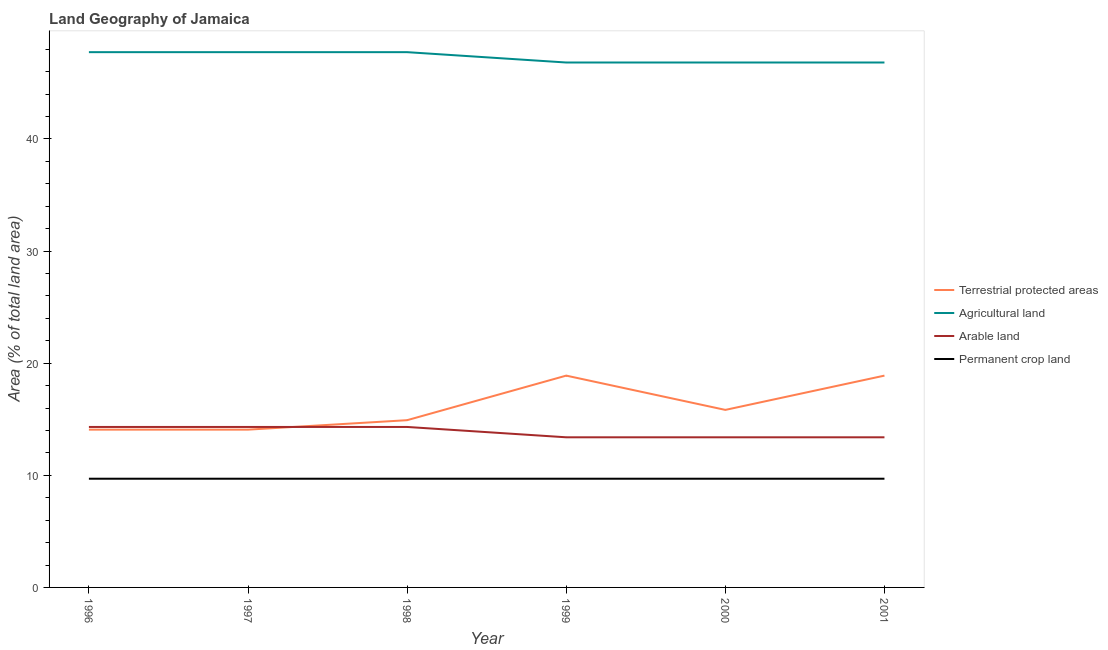How many different coloured lines are there?
Ensure brevity in your answer.  4. Does the line corresponding to percentage of land under terrestrial protection intersect with the line corresponding to percentage of area under permanent crop land?
Give a very brief answer. No. What is the percentage of area under agricultural land in 1997?
Offer a very short reply. 47.74. Across all years, what is the maximum percentage of area under permanent crop land?
Make the answer very short. 9.7. Across all years, what is the minimum percentage of area under permanent crop land?
Provide a short and direct response. 9.7. In which year was the percentage of area under permanent crop land minimum?
Your answer should be compact. 1996. What is the total percentage of area under agricultural land in the graph?
Give a very brief answer. 283.66. What is the difference between the percentage of area under agricultural land in 1996 and that in 2000?
Provide a short and direct response. 0.92. What is the difference between the percentage of land under terrestrial protection in 2001 and the percentage of area under permanent crop land in 1998?
Ensure brevity in your answer.  9.19. What is the average percentage of land under terrestrial protection per year?
Offer a terse response. 16.11. In the year 1997, what is the difference between the percentage of land under terrestrial protection and percentage of area under permanent crop land?
Ensure brevity in your answer.  4.38. What is the ratio of the percentage of land under terrestrial protection in 1998 to that in 2000?
Keep it short and to the point. 0.94. Is the percentage of area under arable land in 1999 less than that in 2001?
Provide a short and direct response. No. What is the difference between the highest and the lowest percentage of land under terrestrial protection?
Your answer should be compact. 4.82. Is the sum of the percentage of area under arable land in 1998 and 2001 greater than the maximum percentage of land under terrestrial protection across all years?
Provide a succinct answer. Yes. Does the percentage of land under terrestrial protection monotonically increase over the years?
Offer a terse response. No. Is the percentage of area under arable land strictly less than the percentage of land under terrestrial protection over the years?
Your answer should be compact. No. Are the values on the major ticks of Y-axis written in scientific E-notation?
Give a very brief answer. No. How many legend labels are there?
Make the answer very short. 4. What is the title of the graph?
Your answer should be very brief. Land Geography of Jamaica. Does "Business regulatory environment" appear as one of the legend labels in the graph?
Provide a short and direct response. No. What is the label or title of the X-axis?
Offer a very short reply. Year. What is the label or title of the Y-axis?
Your answer should be compact. Area (% of total land area). What is the Area (% of total land area) in Terrestrial protected areas in 1996?
Ensure brevity in your answer.  14.07. What is the Area (% of total land area) in Agricultural land in 1996?
Provide a succinct answer. 47.74. What is the Area (% of total land area) of Arable land in 1996?
Your answer should be very brief. 14.31. What is the Area (% of total land area) of Permanent crop land in 1996?
Make the answer very short. 9.7. What is the Area (% of total land area) in Terrestrial protected areas in 1997?
Your answer should be compact. 14.07. What is the Area (% of total land area) of Agricultural land in 1997?
Keep it short and to the point. 47.74. What is the Area (% of total land area) of Arable land in 1997?
Your response must be concise. 14.31. What is the Area (% of total land area) of Permanent crop land in 1997?
Ensure brevity in your answer.  9.7. What is the Area (% of total land area) in Terrestrial protected areas in 1998?
Your answer should be very brief. 14.92. What is the Area (% of total land area) of Agricultural land in 1998?
Ensure brevity in your answer.  47.74. What is the Area (% of total land area) of Arable land in 1998?
Keep it short and to the point. 14.31. What is the Area (% of total land area) in Permanent crop land in 1998?
Provide a succinct answer. 9.7. What is the Area (% of total land area) of Terrestrial protected areas in 1999?
Make the answer very short. 18.89. What is the Area (% of total land area) of Agricultural land in 1999?
Offer a terse response. 46.81. What is the Area (% of total land area) of Arable land in 1999?
Your response must be concise. 13.39. What is the Area (% of total land area) in Permanent crop land in 1999?
Provide a short and direct response. 9.7. What is the Area (% of total land area) of Terrestrial protected areas in 2000?
Ensure brevity in your answer.  15.83. What is the Area (% of total land area) of Agricultural land in 2000?
Your answer should be very brief. 46.81. What is the Area (% of total land area) in Arable land in 2000?
Your answer should be very brief. 13.39. What is the Area (% of total land area) in Permanent crop land in 2000?
Your response must be concise. 9.7. What is the Area (% of total land area) in Terrestrial protected areas in 2001?
Provide a short and direct response. 18.89. What is the Area (% of total land area) in Agricultural land in 2001?
Give a very brief answer. 46.81. What is the Area (% of total land area) in Arable land in 2001?
Provide a succinct answer. 13.39. What is the Area (% of total land area) in Permanent crop land in 2001?
Provide a succinct answer. 9.7. Across all years, what is the maximum Area (% of total land area) in Terrestrial protected areas?
Provide a succinct answer. 18.89. Across all years, what is the maximum Area (% of total land area) of Agricultural land?
Your answer should be compact. 47.74. Across all years, what is the maximum Area (% of total land area) of Arable land?
Make the answer very short. 14.31. Across all years, what is the maximum Area (% of total land area) in Permanent crop land?
Give a very brief answer. 9.7. Across all years, what is the minimum Area (% of total land area) in Terrestrial protected areas?
Offer a very short reply. 14.07. Across all years, what is the minimum Area (% of total land area) in Agricultural land?
Provide a succinct answer. 46.81. Across all years, what is the minimum Area (% of total land area) in Arable land?
Give a very brief answer. 13.39. Across all years, what is the minimum Area (% of total land area) of Permanent crop land?
Offer a terse response. 9.7. What is the total Area (% of total land area) in Terrestrial protected areas in the graph?
Your answer should be compact. 96.67. What is the total Area (% of total land area) of Agricultural land in the graph?
Make the answer very short. 283.66. What is the total Area (% of total land area) of Arable land in the graph?
Keep it short and to the point. 83.1. What is the total Area (% of total land area) in Permanent crop land in the graph?
Make the answer very short. 58.17. What is the difference between the Area (% of total land area) in Terrestrial protected areas in 1996 and that in 1997?
Offer a terse response. 0. What is the difference between the Area (% of total land area) in Agricultural land in 1996 and that in 1997?
Your answer should be compact. 0. What is the difference between the Area (% of total land area) in Arable land in 1996 and that in 1997?
Offer a very short reply. 0. What is the difference between the Area (% of total land area) of Terrestrial protected areas in 1996 and that in 1998?
Your answer should be compact. -0.84. What is the difference between the Area (% of total land area) in Agricultural land in 1996 and that in 1998?
Your answer should be very brief. 0. What is the difference between the Area (% of total land area) in Arable land in 1996 and that in 1998?
Provide a succinct answer. 0. What is the difference between the Area (% of total land area) of Permanent crop land in 1996 and that in 1998?
Offer a very short reply. 0. What is the difference between the Area (% of total land area) of Terrestrial protected areas in 1996 and that in 1999?
Your answer should be very brief. -4.82. What is the difference between the Area (% of total land area) of Agricultural land in 1996 and that in 1999?
Offer a very short reply. 0.92. What is the difference between the Area (% of total land area) of Arable land in 1996 and that in 1999?
Give a very brief answer. 0.92. What is the difference between the Area (% of total land area) of Terrestrial protected areas in 1996 and that in 2000?
Offer a terse response. -1.76. What is the difference between the Area (% of total land area) in Agricultural land in 1996 and that in 2000?
Offer a terse response. 0.92. What is the difference between the Area (% of total land area) in Arable land in 1996 and that in 2000?
Your answer should be compact. 0.92. What is the difference between the Area (% of total land area) in Terrestrial protected areas in 1996 and that in 2001?
Provide a succinct answer. -4.82. What is the difference between the Area (% of total land area) in Agricultural land in 1996 and that in 2001?
Your answer should be compact. 0.92. What is the difference between the Area (% of total land area) in Arable land in 1996 and that in 2001?
Ensure brevity in your answer.  0.92. What is the difference between the Area (% of total land area) in Terrestrial protected areas in 1997 and that in 1998?
Offer a terse response. -0.84. What is the difference between the Area (% of total land area) in Permanent crop land in 1997 and that in 1998?
Your answer should be very brief. 0. What is the difference between the Area (% of total land area) in Terrestrial protected areas in 1997 and that in 1999?
Offer a very short reply. -4.82. What is the difference between the Area (% of total land area) in Agricultural land in 1997 and that in 1999?
Provide a succinct answer. 0.92. What is the difference between the Area (% of total land area) of Arable land in 1997 and that in 1999?
Offer a terse response. 0.92. What is the difference between the Area (% of total land area) in Terrestrial protected areas in 1997 and that in 2000?
Keep it short and to the point. -1.76. What is the difference between the Area (% of total land area) in Agricultural land in 1997 and that in 2000?
Your answer should be very brief. 0.92. What is the difference between the Area (% of total land area) in Arable land in 1997 and that in 2000?
Offer a terse response. 0.92. What is the difference between the Area (% of total land area) in Permanent crop land in 1997 and that in 2000?
Your answer should be compact. 0. What is the difference between the Area (% of total land area) in Terrestrial protected areas in 1997 and that in 2001?
Offer a terse response. -4.82. What is the difference between the Area (% of total land area) in Agricultural land in 1997 and that in 2001?
Keep it short and to the point. 0.92. What is the difference between the Area (% of total land area) of Arable land in 1997 and that in 2001?
Your response must be concise. 0.92. What is the difference between the Area (% of total land area) in Permanent crop land in 1997 and that in 2001?
Your answer should be very brief. 0. What is the difference between the Area (% of total land area) of Terrestrial protected areas in 1998 and that in 1999?
Provide a short and direct response. -3.97. What is the difference between the Area (% of total land area) in Agricultural land in 1998 and that in 1999?
Your response must be concise. 0.92. What is the difference between the Area (% of total land area) in Arable land in 1998 and that in 1999?
Make the answer very short. 0.92. What is the difference between the Area (% of total land area) of Terrestrial protected areas in 1998 and that in 2000?
Your answer should be compact. -0.92. What is the difference between the Area (% of total land area) of Agricultural land in 1998 and that in 2000?
Your response must be concise. 0.92. What is the difference between the Area (% of total land area) in Arable land in 1998 and that in 2000?
Offer a very short reply. 0.92. What is the difference between the Area (% of total land area) of Permanent crop land in 1998 and that in 2000?
Your response must be concise. 0. What is the difference between the Area (% of total land area) in Terrestrial protected areas in 1998 and that in 2001?
Provide a succinct answer. -3.97. What is the difference between the Area (% of total land area) of Agricultural land in 1998 and that in 2001?
Offer a very short reply. 0.92. What is the difference between the Area (% of total land area) in Arable land in 1998 and that in 2001?
Your answer should be compact. 0.92. What is the difference between the Area (% of total land area) in Terrestrial protected areas in 1999 and that in 2000?
Keep it short and to the point. 3.06. What is the difference between the Area (% of total land area) of Agricultural land in 1999 and that in 2000?
Provide a succinct answer. 0. What is the difference between the Area (% of total land area) in Arable land in 1999 and that in 2000?
Offer a very short reply. 0. What is the difference between the Area (% of total land area) in Terrestrial protected areas in 1999 and that in 2001?
Give a very brief answer. 0. What is the difference between the Area (% of total land area) of Agricultural land in 1999 and that in 2001?
Provide a succinct answer. 0. What is the difference between the Area (% of total land area) of Arable land in 1999 and that in 2001?
Ensure brevity in your answer.  0. What is the difference between the Area (% of total land area) of Terrestrial protected areas in 2000 and that in 2001?
Your answer should be very brief. -3.06. What is the difference between the Area (% of total land area) of Agricultural land in 2000 and that in 2001?
Your response must be concise. 0. What is the difference between the Area (% of total land area) in Terrestrial protected areas in 1996 and the Area (% of total land area) in Agricultural land in 1997?
Your answer should be very brief. -33.67. What is the difference between the Area (% of total land area) of Terrestrial protected areas in 1996 and the Area (% of total land area) of Arable land in 1997?
Provide a short and direct response. -0.24. What is the difference between the Area (% of total land area) in Terrestrial protected areas in 1996 and the Area (% of total land area) in Permanent crop land in 1997?
Ensure brevity in your answer.  4.38. What is the difference between the Area (% of total land area) in Agricultural land in 1996 and the Area (% of total land area) in Arable land in 1997?
Provide a succinct answer. 33.43. What is the difference between the Area (% of total land area) of Agricultural land in 1996 and the Area (% of total land area) of Permanent crop land in 1997?
Offer a very short reply. 38.04. What is the difference between the Area (% of total land area) of Arable land in 1996 and the Area (% of total land area) of Permanent crop land in 1997?
Provide a succinct answer. 4.62. What is the difference between the Area (% of total land area) in Terrestrial protected areas in 1996 and the Area (% of total land area) in Agricultural land in 1998?
Your response must be concise. -33.67. What is the difference between the Area (% of total land area) of Terrestrial protected areas in 1996 and the Area (% of total land area) of Arable land in 1998?
Your response must be concise. -0.24. What is the difference between the Area (% of total land area) of Terrestrial protected areas in 1996 and the Area (% of total land area) of Permanent crop land in 1998?
Your answer should be very brief. 4.38. What is the difference between the Area (% of total land area) in Agricultural land in 1996 and the Area (% of total land area) in Arable land in 1998?
Provide a short and direct response. 33.43. What is the difference between the Area (% of total land area) of Agricultural land in 1996 and the Area (% of total land area) of Permanent crop land in 1998?
Provide a short and direct response. 38.04. What is the difference between the Area (% of total land area) of Arable land in 1996 and the Area (% of total land area) of Permanent crop land in 1998?
Your answer should be very brief. 4.62. What is the difference between the Area (% of total land area) of Terrestrial protected areas in 1996 and the Area (% of total land area) of Agricultural land in 1999?
Your response must be concise. -32.74. What is the difference between the Area (% of total land area) in Terrestrial protected areas in 1996 and the Area (% of total land area) in Arable land in 1999?
Offer a terse response. 0.68. What is the difference between the Area (% of total land area) in Terrestrial protected areas in 1996 and the Area (% of total land area) in Permanent crop land in 1999?
Provide a short and direct response. 4.38. What is the difference between the Area (% of total land area) of Agricultural land in 1996 and the Area (% of total land area) of Arable land in 1999?
Give a very brief answer. 34.35. What is the difference between the Area (% of total land area) in Agricultural land in 1996 and the Area (% of total land area) in Permanent crop land in 1999?
Your answer should be very brief. 38.04. What is the difference between the Area (% of total land area) in Arable land in 1996 and the Area (% of total land area) in Permanent crop land in 1999?
Provide a short and direct response. 4.62. What is the difference between the Area (% of total land area) of Terrestrial protected areas in 1996 and the Area (% of total land area) of Agricultural land in 2000?
Make the answer very short. -32.74. What is the difference between the Area (% of total land area) in Terrestrial protected areas in 1996 and the Area (% of total land area) in Arable land in 2000?
Provide a succinct answer. 0.68. What is the difference between the Area (% of total land area) of Terrestrial protected areas in 1996 and the Area (% of total land area) of Permanent crop land in 2000?
Your response must be concise. 4.38. What is the difference between the Area (% of total land area) of Agricultural land in 1996 and the Area (% of total land area) of Arable land in 2000?
Your answer should be compact. 34.35. What is the difference between the Area (% of total land area) of Agricultural land in 1996 and the Area (% of total land area) of Permanent crop land in 2000?
Give a very brief answer. 38.04. What is the difference between the Area (% of total land area) in Arable land in 1996 and the Area (% of total land area) in Permanent crop land in 2000?
Offer a very short reply. 4.62. What is the difference between the Area (% of total land area) of Terrestrial protected areas in 1996 and the Area (% of total land area) of Agricultural land in 2001?
Your answer should be very brief. -32.74. What is the difference between the Area (% of total land area) in Terrestrial protected areas in 1996 and the Area (% of total land area) in Arable land in 2001?
Your answer should be compact. 0.68. What is the difference between the Area (% of total land area) of Terrestrial protected areas in 1996 and the Area (% of total land area) of Permanent crop land in 2001?
Offer a very short reply. 4.38. What is the difference between the Area (% of total land area) of Agricultural land in 1996 and the Area (% of total land area) of Arable land in 2001?
Make the answer very short. 34.35. What is the difference between the Area (% of total land area) in Agricultural land in 1996 and the Area (% of total land area) in Permanent crop land in 2001?
Your response must be concise. 38.04. What is the difference between the Area (% of total land area) of Arable land in 1996 and the Area (% of total land area) of Permanent crop land in 2001?
Ensure brevity in your answer.  4.62. What is the difference between the Area (% of total land area) in Terrestrial protected areas in 1997 and the Area (% of total land area) in Agricultural land in 1998?
Give a very brief answer. -33.67. What is the difference between the Area (% of total land area) in Terrestrial protected areas in 1997 and the Area (% of total land area) in Arable land in 1998?
Make the answer very short. -0.24. What is the difference between the Area (% of total land area) of Terrestrial protected areas in 1997 and the Area (% of total land area) of Permanent crop land in 1998?
Offer a very short reply. 4.38. What is the difference between the Area (% of total land area) of Agricultural land in 1997 and the Area (% of total land area) of Arable land in 1998?
Ensure brevity in your answer.  33.43. What is the difference between the Area (% of total land area) of Agricultural land in 1997 and the Area (% of total land area) of Permanent crop land in 1998?
Provide a short and direct response. 38.04. What is the difference between the Area (% of total land area) in Arable land in 1997 and the Area (% of total land area) in Permanent crop land in 1998?
Ensure brevity in your answer.  4.62. What is the difference between the Area (% of total land area) of Terrestrial protected areas in 1997 and the Area (% of total land area) of Agricultural land in 1999?
Make the answer very short. -32.74. What is the difference between the Area (% of total land area) in Terrestrial protected areas in 1997 and the Area (% of total land area) in Arable land in 1999?
Provide a succinct answer. 0.68. What is the difference between the Area (% of total land area) in Terrestrial protected areas in 1997 and the Area (% of total land area) in Permanent crop land in 1999?
Offer a terse response. 4.38. What is the difference between the Area (% of total land area) in Agricultural land in 1997 and the Area (% of total land area) in Arable land in 1999?
Provide a succinct answer. 34.35. What is the difference between the Area (% of total land area) of Agricultural land in 1997 and the Area (% of total land area) of Permanent crop land in 1999?
Make the answer very short. 38.04. What is the difference between the Area (% of total land area) of Arable land in 1997 and the Area (% of total land area) of Permanent crop land in 1999?
Provide a short and direct response. 4.62. What is the difference between the Area (% of total land area) in Terrestrial protected areas in 1997 and the Area (% of total land area) in Agricultural land in 2000?
Your response must be concise. -32.74. What is the difference between the Area (% of total land area) in Terrestrial protected areas in 1997 and the Area (% of total land area) in Arable land in 2000?
Make the answer very short. 0.68. What is the difference between the Area (% of total land area) of Terrestrial protected areas in 1997 and the Area (% of total land area) of Permanent crop land in 2000?
Provide a succinct answer. 4.38. What is the difference between the Area (% of total land area) in Agricultural land in 1997 and the Area (% of total land area) in Arable land in 2000?
Your answer should be very brief. 34.35. What is the difference between the Area (% of total land area) in Agricultural land in 1997 and the Area (% of total land area) in Permanent crop land in 2000?
Give a very brief answer. 38.04. What is the difference between the Area (% of total land area) in Arable land in 1997 and the Area (% of total land area) in Permanent crop land in 2000?
Give a very brief answer. 4.62. What is the difference between the Area (% of total land area) in Terrestrial protected areas in 1997 and the Area (% of total land area) in Agricultural land in 2001?
Provide a succinct answer. -32.74. What is the difference between the Area (% of total land area) in Terrestrial protected areas in 1997 and the Area (% of total land area) in Arable land in 2001?
Provide a short and direct response. 0.68. What is the difference between the Area (% of total land area) in Terrestrial protected areas in 1997 and the Area (% of total land area) in Permanent crop land in 2001?
Give a very brief answer. 4.38. What is the difference between the Area (% of total land area) in Agricultural land in 1997 and the Area (% of total land area) in Arable land in 2001?
Keep it short and to the point. 34.35. What is the difference between the Area (% of total land area) of Agricultural land in 1997 and the Area (% of total land area) of Permanent crop land in 2001?
Your answer should be very brief. 38.04. What is the difference between the Area (% of total land area) in Arable land in 1997 and the Area (% of total land area) in Permanent crop land in 2001?
Ensure brevity in your answer.  4.62. What is the difference between the Area (% of total land area) in Terrestrial protected areas in 1998 and the Area (% of total land area) in Agricultural land in 1999?
Provide a succinct answer. -31.9. What is the difference between the Area (% of total land area) in Terrestrial protected areas in 1998 and the Area (% of total land area) in Arable land in 1999?
Offer a terse response. 1.53. What is the difference between the Area (% of total land area) of Terrestrial protected areas in 1998 and the Area (% of total land area) of Permanent crop land in 1999?
Make the answer very short. 5.22. What is the difference between the Area (% of total land area) in Agricultural land in 1998 and the Area (% of total land area) in Arable land in 1999?
Your answer should be very brief. 34.35. What is the difference between the Area (% of total land area) of Agricultural land in 1998 and the Area (% of total land area) of Permanent crop land in 1999?
Provide a succinct answer. 38.04. What is the difference between the Area (% of total land area) of Arable land in 1998 and the Area (% of total land area) of Permanent crop land in 1999?
Your response must be concise. 4.62. What is the difference between the Area (% of total land area) of Terrestrial protected areas in 1998 and the Area (% of total land area) of Agricultural land in 2000?
Offer a terse response. -31.9. What is the difference between the Area (% of total land area) of Terrestrial protected areas in 1998 and the Area (% of total land area) of Arable land in 2000?
Provide a short and direct response. 1.53. What is the difference between the Area (% of total land area) of Terrestrial protected areas in 1998 and the Area (% of total land area) of Permanent crop land in 2000?
Your answer should be very brief. 5.22. What is the difference between the Area (% of total land area) in Agricultural land in 1998 and the Area (% of total land area) in Arable land in 2000?
Provide a succinct answer. 34.35. What is the difference between the Area (% of total land area) of Agricultural land in 1998 and the Area (% of total land area) of Permanent crop land in 2000?
Ensure brevity in your answer.  38.04. What is the difference between the Area (% of total land area) in Arable land in 1998 and the Area (% of total land area) in Permanent crop land in 2000?
Your response must be concise. 4.62. What is the difference between the Area (% of total land area) of Terrestrial protected areas in 1998 and the Area (% of total land area) of Agricultural land in 2001?
Offer a terse response. -31.9. What is the difference between the Area (% of total land area) of Terrestrial protected areas in 1998 and the Area (% of total land area) of Arable land in 2001?
Provide a short and direct response. 1.53. What is the difference between the Area (% of total land area) of Terrestrial protected areas in 1998 and the Area (% of total land area) of Permanent crop land in 2001?
Give a very brief answer. 5.22. What is the difference between the Area (% of total land area) of Agricultural land in 1998 and the Area (% of total land area) of Arable land in 2001?
Keep it short and to the point. 34.35. What is the difference between the Area (% of total land area) in Agricultural land in 1998 and the Area (% of total land area) in Permanent crop land in 2001?
Your answer should be very brief. 38.04. What is the difference between the Area (% of total land area) in Arable land in 1998 and the Area (% of total land area) in Permanent crop land in 2001?
Provide a succinct answer. 4.62. What is the difference between the Area (% of total land area) in Terrestrial protected areas in 1999 and the Area (% of total land area) in Agricultural land in 2000?
Keep it short and to the point. -27.92. What is the difference between the Area (% of total land area) in Terrestrial protected areas in 1999 and the Area (% of total land area) in Arable land in 2000?
Provide a succinct answer. 5.5. What is the difference between the Area (% of total land area) of Terrestrial protected areas in 1999 and the Area (% of total land area) of Permanent crop land in 2000?
Ensure brevity in your answer.  9.19. What is the difference between the Area (% of total land area) in Agricultural land in 1999 and the Area (% of total land area) in Arable land in 2000?
Keep it short and to the point. 33.43. What is the difference between the Area (% of total land area) in Agricultural land in 1999 and the Area (% of total land area) in Permanent crop land in 2000?
Your answer should be very brief. 37.12. What is the difference between the Area (% of total land area) of Arable land in 1999 and the Area (% of total land area) of Permanent crop land in 2000?
Your answer should be compact. 3.69. What is the difference between the Area (% of total land area) in Terrestrial protected areas in 1999 and the Area (% of total land area) in Agricultural land in 2001?
Make the answer very short. -27.92. What is the difference between the Area (% of total land area) in Terrestrial protected areas in 1999 and the Area (% of total land area) in Arable land in 2001?
Your response must be concise. 5.5. What is the difference between the Area (% of total land area) of Terrestrial protected areas in 1999 and the Area (% of total land area) of Permanent crop land in 2001?
Provide a short and direct response. 9.19. What is the difference between the Area (% of total land area) in Agricultural land in 1999 and the Area (% of total land area) in Arable land in 2001?
Offer a very short reply. 33.43. What is the difference between the Area (% of total land area) of Agricultural land in 1999 and the Area (% of total land area) of Permanent crop land in 2001?
Ensure brevity in your answer.  37.12. What is the difference between the Area (% of total land area) of Arable land in 1999 and the Area (% of total land area) of Permanent crop land in 2001?
Provide a short and direct response. 3.69. What is the difference between the Area (% of total land area) in Terrestrial protected areas in 2000 and the Area (% of total land area) in Agricultural land in 2001?
Ensure brevity in your answer.  -30.98. What is the difference between the Area (% of total land area) in Terrestrial protected areas in 2000 and the Area (% of total land area) in Arable land in 2001?
Your answer should be very brief. 2.44. What is the difference between the Area (% of total land area) in Terrestrial protected areas in 2000 and the Area (% of total land area) in Permanent crop land in 2001?
Ensure brevity in your answer.  6.14. What is the difference between the Area (% of total land area) of Agricultural land in 2000 and the Area (% of total land area) of Arable land in 2001?
Your answer should be very brief. 33.43. What is the difference between the Area (% of total land area) of Agricultural land in 2000 and the Area (% of total land area) of Permanent crop land in 2001?
Give a very brief answer. 37.12. What is the difference between the Area (% of total land area) of Arable land in 2000 and the Area (% of total land area) of Permanent crop land in 2001?
Your answer should be compact. 3.69. What is the average Area (% of total land area) of Terrestrial protected areas per year?
Offer a very short reply. 16.11. What is the average Area (% of total land area) in Agricultural land per year?
Ensure brevity in your answer.  47.28. What is the average Area (% of total land area) of Arable land per year?
Provide a succinct answer. 13.85. What is the average Area (% of total land area) in Permanent crop land per year?
Offer a very short reply. 9.7. In the year 1996, what is the difference between the Area (% of total land area) in Terrestrial protected areas and Area (% of total land area) in Agricultural land?
Your answer should be very brief. -33.67. In the year 1996, what is the difference between the Area (% of total land area) of Terrestrial protected areas and Area (% of total land area) of Arable land?
Make the answer very short. -0.24. In the year 1996, what is the difference between the Area (% of total land area) in Terrestrial protected areas and Area (% of total land area) in Permanent crop land?
Offer a terse response. 4.38. In the year 1996, what is the difference between the Area (% of total land area) of Agricultural land and Area (% of total land area) of Arable land?
Offer a terse response. 33.43. In the year 1996, what is the difference between the Area (% of total land area) of Agricultural land and Area (% of total land area) of Permanent crop land?
Offer a terse response. 38.04. In the year 1996, what is the difference between the Area (% of total land area) of Arable land and Area (% of total land area) of Permanent crop land?
Your answer should be compact. 4.62. In the year 1997, what is the difference between the Area (% of total land area) in Terrestrial protected areas and Area (% of total land area) in Agricultural land?
Your answer should be compact. -33.67. In the year 1997, what is the difference between the Area (% of total land area) in Terrestrial protected areas and Area (% of total land area) in Arable land?
Ensure brevity in your answer.  -0.24. In the year 1997, what is the difference between the Area (% of total land area) of Terrestrial protected areas and Area (% of total land area) of Permanent crop land?
Provide a short and direct response. 4.38. In the year 1997, what is the difference between the Area (% of total land area) of Agricultural land and Area (% of total land area) of Arable land?
Your response must be concise. 33.43. In the year 1997, what is the difference between the Area (% of total land area) in Agricultural land and Area (% of total land area) in Permanent crop land?
Ensure brevity in your answer.  38.04. In the year 1997, what is the difference between the Area (% of total land area) in Arable land and Area (% of total land area) in Permanent crop land?
Offer a terse response. 4.62. In the year 1998, what is the difference between the Area (% of total land area) of Terrestrial protected areas and Area (% of total land area) of Agricultural land?
Give a very brief answer. -32.82. In the year 1998, what is the difference between the Area (% of total land area) of Terrestrial protected areas and Area (% of total land area) of Arable land?
Ensure brevity in your answer.  0.6. In the year 1998, what is the difference between the Area (% of total land area) of Terrestrial protected areas and Area (% of total land area) of Permanent crop land?
Provide a short and direct response. 5.22. In the year 1998, what is the difference between the Area (% of total land area) in Agricultural land and Area (% of total land area) in Arable land?
Keep it short and to the point. 33.43. In the year 1998, what is the difference between the Area (% of total land area) in Agricultural land and Area (% of total land area) in Permanent crop land?
Offer a very short reply. 38.04. In the year 1998, what is the difference between the Area (% of total land area) of Arable land and Area (% of total land area) of Permanent crop land?
Make the answer very short. 4.62. In the year 1999, what is the difference between the Area (% of total land area) of Terrestrial protected areas and Area (% of total land area) of Agricultural land?
Provide a short and direct response. -27.92. In the year 1999, what is the difference between the Area (% of total land area) in Terrestrial protected areas and Area (% of total land area) in Arable land?
Offer a terse response. 5.5. In the year 1999, what is the difference between the Area (% of total land area) in Terrestrial protected areas and Area (% of total land area) in Permanent crop land?
Provide a succinct answer. 9.19. In the year 1999, what is the difference between the Area (% of total land area) in Agricultural land and Area (% of total land area) in Arable land?
Provide a short and direct response. 33.43. In the year 1999, what is the difference between the Area (% of total land area) in Agricultural land and Area (% of total land area) in Permanent crop land?
Provide a short and direct response. 37.12. In the year 1999, what is the difference between the Area (% of total land area) in Arable land and Area (% of total land area) in Permanent crop land?
Your response must be concise. 3.69. In the year 2000, what is the difference between the Area (% of total land area) of Terrestrial protected areas and Area (% of total land area) of Agricultural land?
Offer a terse response. -30.98. In the year 2000, what is the difference between the Area (% of total land area) in Terrestrial protected areas and Area (% of total land area) in Arable land?
Keep it short and to the point. 2.44. In the year 2000, what is the difference between the Area (% of total land area) in Terrestrial protected areas and Area (% of total land area) in Permanent crop land?
Ensure brevity in your answer.  6.14. In the year 2000, what is the difference between the Area (% of total land area) of Agricultural land and Area (% of total land area) of Arable land?
Your answer should be very brief. 33.43. In the year 2000, what is the difference between the Area (% of total land area) of Agricultural land and Area (% of total land area) of Permanent crop land?
Your response must be concise. 37.12. In the year 2000, what is the difference between the Area (% of total land area) of Arable land and Area (% of total land area) of Permanent crop land?
Give a very brief answer. 3.69. In the year 2001, what is the difference between the Area (% of total land area) of Terrestrial protected areas and Area (% of total land area) of Agricultural land?
Offer a very short reply. -27.92. In the year 2001, what is the difference between the Area (% of total land area) in Terrestrial protected areas and Area (% of total land area) in Arable land?
Keep it short and to the point. 5.5. In the year 2001, what is the difference between the Area (% of total land area) in Terrestrial protected areas and Area (% of total land area) in Permanent crop land?
Your answer should be compact. 9.19. In the year 2001, what is the difference between the Area (% of total land area) in Agricultural land and Area (% of total land area) in Arable land?
Provide a succinct answer. 33.43. In the year 2001, what is the difference between the Area (% of total land area) in Agricultural land and Area (% of total land area) in Permanent crop land?
Your answer should be compact. 37.12. In the year 2001, what is the difference between the Area (% of total land area) in Arable land and Area (% of total land area) in Permanent crop land?
Provide a succinct answer. 3.69. What is the ratio of the Area (% of total land area) in Terrestrial protected areas in 1996 to that in 1997?
Your response must be concise. 1. What is the ratio of the Area (% of total land area) in Agricultural land in 1996 to that in 1997?
Provide a succinct answer. 1. What is the ratio of the Area (% of total land area) of Arable land in 1996 to that in 1997?
Your answer should be very brief. 1. What is the ratio of the Area (% of total land area) in Terrestrial protected areas in 1996 to that in 1998?
Your response must be concise. 0.94. What is the ratio of the Area (% of total land area) in Agricultural land in 1996 to that in 1998?
Offer a terse response. 1. What is the ratio of the Area (% of total land area) of Permanent crop land in 1996 to that in 1998?
Make the answer very short. 1. What is the ratio of the Area (% of total land area) in Terrestrial protected areas in 1996 to that in 1999?
Your answer should be very brief. 0.74. What is the ratio of the Area (% of total land area) in Agricultural land in 1996 to that in 1999?
Offer a very short reply. 1.02. What is the ratio of the Area (% of total land area) in Arable land in 1996 to that in 1999?
Make the answer very short. 1.07. What is the ratio of the Area (% of total land area) in Terrestrial protected areas in 1996 to that in 2000?
Make the answer very short. 0.89. What is the ratio of the Area (% of total land area) in Agricultural land in 1996 to that in 2000?
Keep it short and to the point. 1.02. What is the ratio of the Area (% of total land area) in Arable land in 1996 to that in 2000?
Keep it short and to the point. 1.07. What is the ratio of the Area (% of total land area) in Permanent crop land in 1996 to that in 2000?
Provide a short and direct response. 1. What is the ratio of the Area (% of total land area) of Terrestrial protected areas in 1996 to that in 2001?
Offer a very short reply. 0.74. What is the ratio of the Area (% of total land area) in Agricultural land in 1996 to that in 2001?
Give a very brief answer. 1.02. What is the ratio of the Area (% of total land area) in Arable land in 1996 to that in 2001?
Keep it short and to the point. 1.07. What is the ratio of the Area (% of total land area) of Permanent crop land in 1996 to that in 2001?
Give a very brief answer. 1. What is the ratio of the Area (% of total land area) in Terrestrial protected areas in 1997 to that in 1998?
Your answer should be compact. 0.94. What is the ratio of the Area (% of total land area) of Terrestrial protected areas in 1997 to that in 1999?
Your answer should be very brief. 0.74. What is the ratio of the Area (% of total land area) in Agricultural land in 1997 to that in 1999?
Make the answer very short. 1.02. What is the ratio of the Area (% of total land area) of Arable land in 1997 to that in 1999?
Your answer should be compact. 1.07. What is the ratio of the Area (% of total land area) in Permanent crop land in 1997 to that in 1999?
Keep it short and to the point. 1. What is the ratio of the Area (% of total land area) in Terrestrial protected areas in 1997 to that in 2000?
Offer a very short reply. 0.89. What is the ratio of the Area (% of total land area) in Agricultural land in 1997 to that in 2000?
Your answer should be very brief. 1.02. What is the ratio of the Area (% of total land area) in Arable land in 1997 to that in 2000?
Your answer should be very brief. 1.07. What is the ratio of the Area (% of total land area) in Permanent crop land in 1997 to that in 2000?
Keep it short and to the point. 1. What is the ratio of the Area (% of total land area) of Terrestrial protected areas in 1997 to that in 2001?
Provide a short and direct response. 0.74. What is the ratio of the Area (% of total land area) in Agricultural land in 1997 to that in 2001?
Keep it short and to the point. 1.02. What is the ratio of the Area (% of total land area) in Arable land in 1997 to that in 2001?
Offer a terse response. 1.07. What is the ratio of the Area (% of total land area) in Terrestrial protected areas in 1998 to that in 1999?
Give a very brief answer. 0.79. What is the ratio of the Area (% of total land area) of Agricultural land in 1998 to that in 1999?
Give a very brief answer. 1.02. What is the ratio of the Area (% of total land area) in Arable land in 1998 to that in 1999?
Your response must be concise. 1.07. What is the ratio of the Area (% of total land area) of Terrestrial protected areas in 1998 to that in 2000?
Provide a succinct answer. 0.94. What is the ratio of the Area (% of total land area) of Agricultural land in 1998 to that in 2000?
Your answer should be very brief. 1.02. What is the ratio of the Area (% of total land area) in Arable land in 1998 to that in 2000?
Provide a succinct answer. 1.07. What is the ratio of the Area (% of total land area) in Terrestrial protected areas in 1998 to that in 2001?
Keep it short and to the point. 0.79. What is the ratio of the Area (% of total land area) of Agricultural land in 1998 to that in 2001?
Provide a succinct answer. 1.02. What is the ratio of the Area (% of total land area) in Arable land in 1998 to that in 2001?
Your answer should be compact. 1.07. What is the ratio of the Area (% of total land area) of Terrestrial protected areas in 1999 to that in 2000?
Offer a very short reply. 1.19. What is the ratio of the Area (% of total land area) of Arable land in 1999 to that in 2000?
Ensure brevity in your answer.  1. What is the ratio of the Area (% of total land area) of Permanent crop land in 1999 to that in 2000?
Offer a very short reply. 1. What is the ratio of the Area (% of total land area) in Agricultural land in 1999 to that in 2001?
Ensure brevity in your answer.  1. What is the ratio of the Area (% of total land area) of Arable land in 1999 to that in 2001?
Provide a short and direct response. 1. What is the ratio of the Area (% of total land area) of Terrestrial protected areas in 2000 to that in 2001?
Offer a very short reply. 0.84. What is the ratio of the Area (% of total land area) in Agricultural land in 2000 to that in 2001?
Ensure brevity in your answer.  1. What is the ratio of the Area (% of total land area) in Arable land in 2000 to that in 2001?
Give a very brief answer. 1. What is the difference between the highest and the second highest Area (% of total land area) in Permanent crop land?
Your answer should be very brief. 0. What is the difference between the highest and the lowest Area (% of total land area) in Terrestrial protected areas?
Offer a very short reply. 4.82. What is the difference between the highest and the lowest Area (% of total land area) of Agricultural land?
Keep it short and to the point. 0.92. What is the difference between the highest and the lowest Area (% of total land area) of Arable land?
Provide a succinct answer. 0.92. What is the difference between the highest and the lowest Area (% of total land area) in Permanent crop land?
Your answer should be compact. 0. 